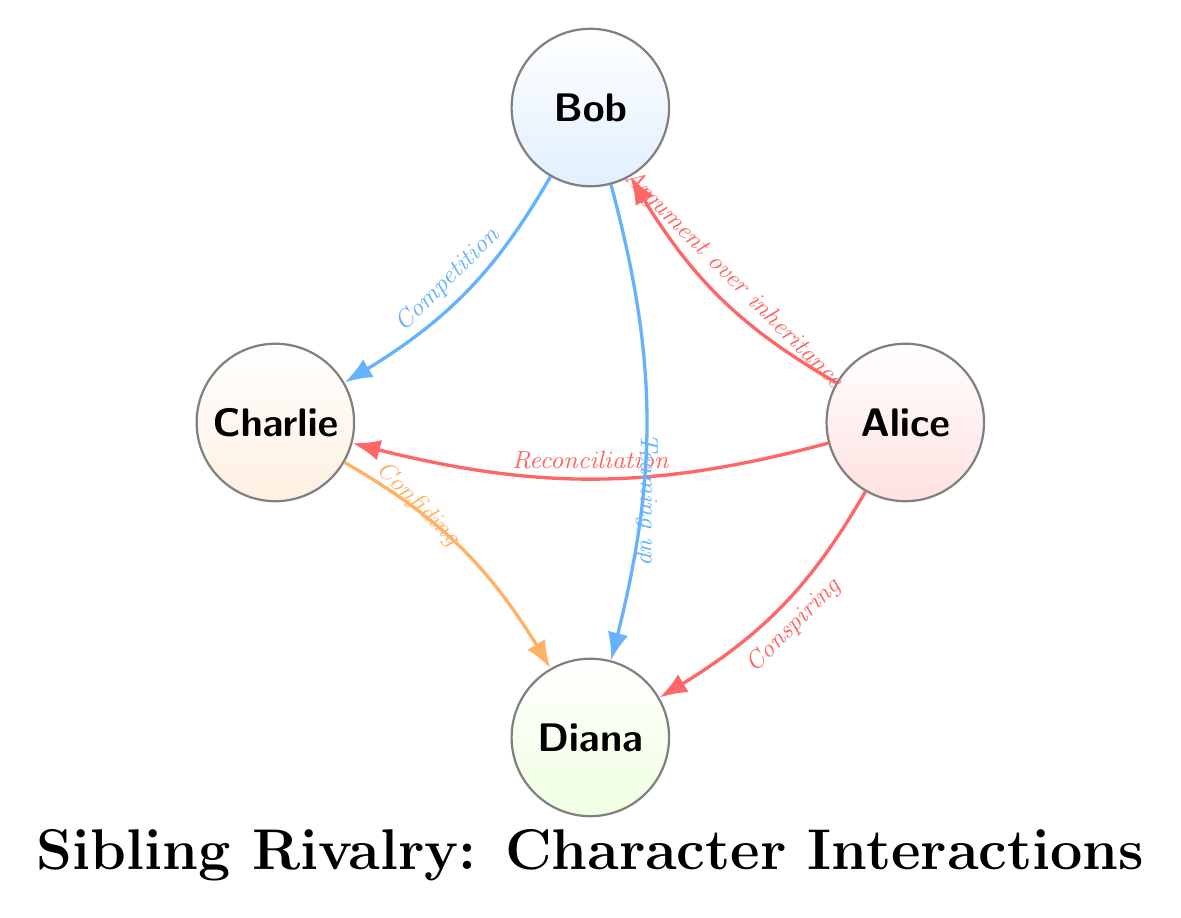What is the total number of characters depicted in the diagram? The diagram includes four distinct characters: Alice, Bob, Charlie, and Diana. The total count of these characters is simply four.
Answer: 4 Which character interacts with Bob in the context of "Argument over inheritance"? The diagram shows an interaction labeled "Argument over inheritance" directly stemming from Alice to Bob. Therefore, Alice is the character interacting with Bob in this scene.
Answer: Alice What scene involves Charlie and Diana? The interaction between Charlie and Diana is described as "Confiding in each other about family secrets." This indicates that the scene involving both characters is centered around this element of trust.
Answer: Confiding in each other about family secrets How many total interactions are depicted in the diagram? By counting each interaction line drawn between characters, there are a total of six interactions present in the diagram.
Answer: 6 Which two characters conspire against Bob? Looking at the interactions, the line from Alice to Diana is labeled "Conspiring against Bob in secret," indicating that Alice and Diana are the two characters engaging in this conspiracy.
Answer: Alice and Diana Which character has the most interactions in the diagram? Reviewing the interactions, Alice connects with Bob, Charlie, and Diana for a total of three distinct interactions. Therefore, Alice is the character with the most interactions in the diagram.
Answer: Alice What is the relationship type between Bob and Charlie? The diagram indicates a competition for parental approval that exists between Bob and Charlie, which describes the nature of their interaction.
Answer: Competition for parental approval How does the diagram reflect sibling rivalry? The interactions among the characters are centered around conflict, competition, and conspiracy, all key themes that highlight sibling rivalry, as seen through various interactions between characters.
Answer: Conflict, competition, conspiracy 